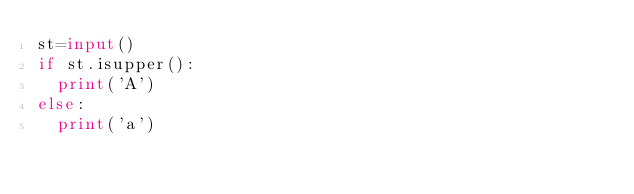Convert code to text. <code><loc_0><loc_0><loc_500><loc_500><_Python_>st=input()
if st.isupper():
  print('A')
else:
  print('a')</code> 